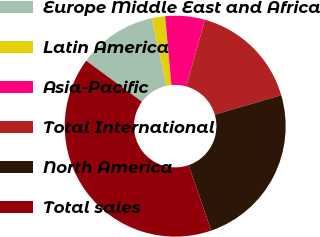<chart> <loc_0><loc_0><loc_500><loc_500><pie_chart><fcel>Europe Middle East and Africa<fcel>Latin America<fcel>Asia-Pacific<fcel>Total International<fcel>North America<fcel>Total sales<nl><fcel>11.51%<fcel>1.95%<fcel>5.79%<fcel>16.15%<fcel>24.22%<fcel>40.37%<nl></chart> 